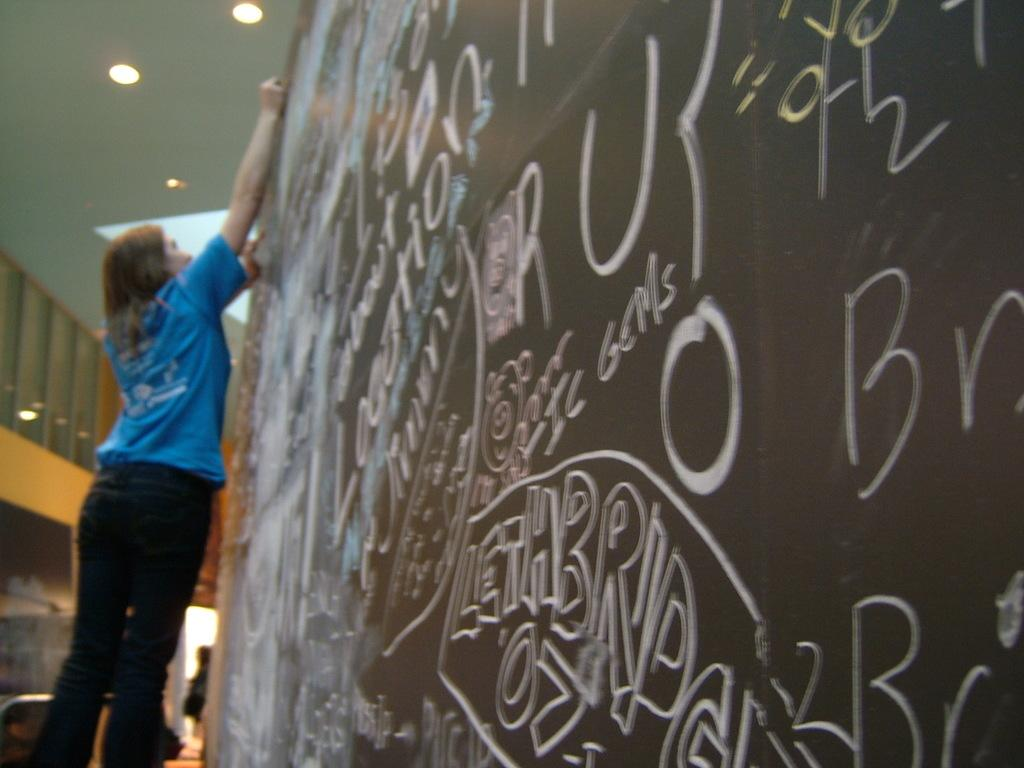What is the main object in the image? There is a blackboard in the image. What is written or drawn on the blackboard? The blackboard has text on it. Who is present in the image? There is a woman standing in the image. What can be seen in the background of the image? In the background, there are lights, the ceiling, a wall, and objects visible. What type of bread is the woman holding in the image? There is no bread present in the image. What degree does the woman have, as indicated by the text on the blackboard? The text on the blackboard does not mention any degrees or qualifications of the woman. 